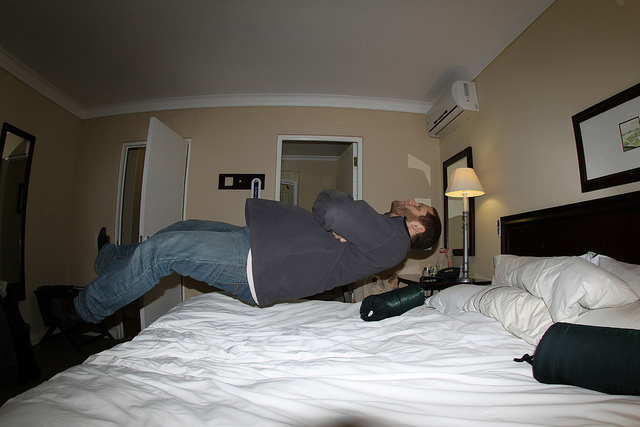What mood does this floating pose convey and why? The floating pose conveys a sense of playfulness and whimsy. It's an unusual and lighthearted scene that breaks from the ordinary—seeing a person seemingly defy gravity in an everyday setting like a hotel room sparks the imagination and injects a sense of fantasy into the mundane. 